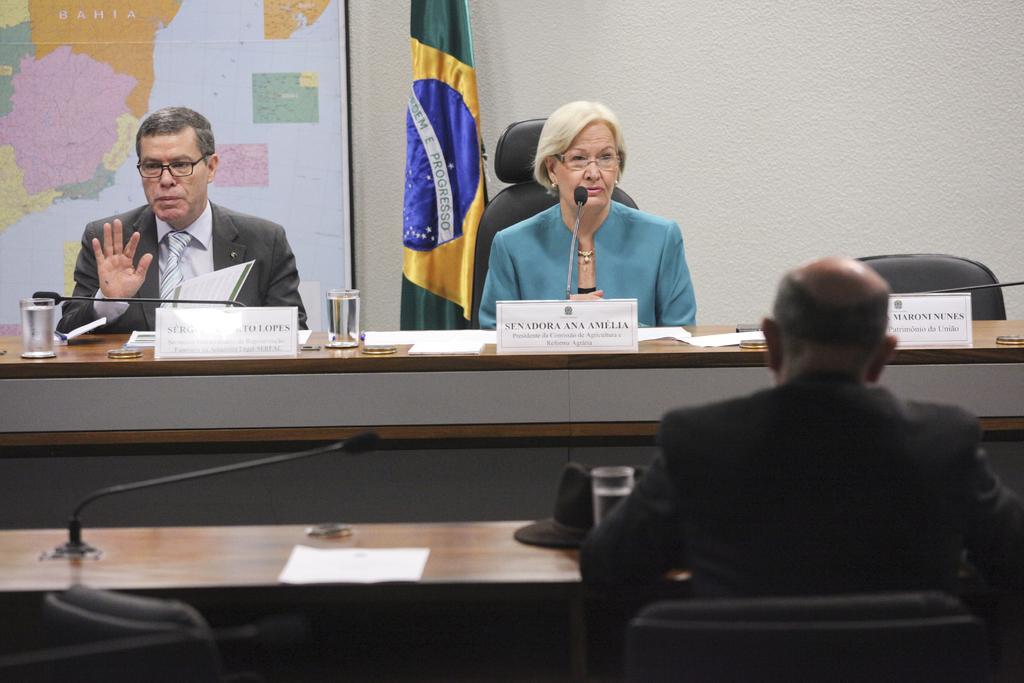Describe this image in one or two sentences. In the image in the center we can see two persons were sitting. In front of them we can see the table,on table we can see some objects. Coming to the background we can see the map,flag and wall. In front of them we can see one man sitting on the chair. Beside him we can see one more table. 